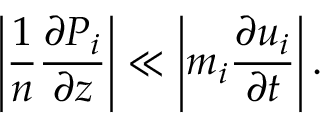Convert formula to latex. <formula><loc_0><loc_0><loc_500><loc_500>\left | \frac { 1 } { n } \frac { \partial P _ { i } } { \partial z } \right | \ll \left | m _ { i } \frac { \partial u _ { i } } { \partial t } \right | .</formula> 